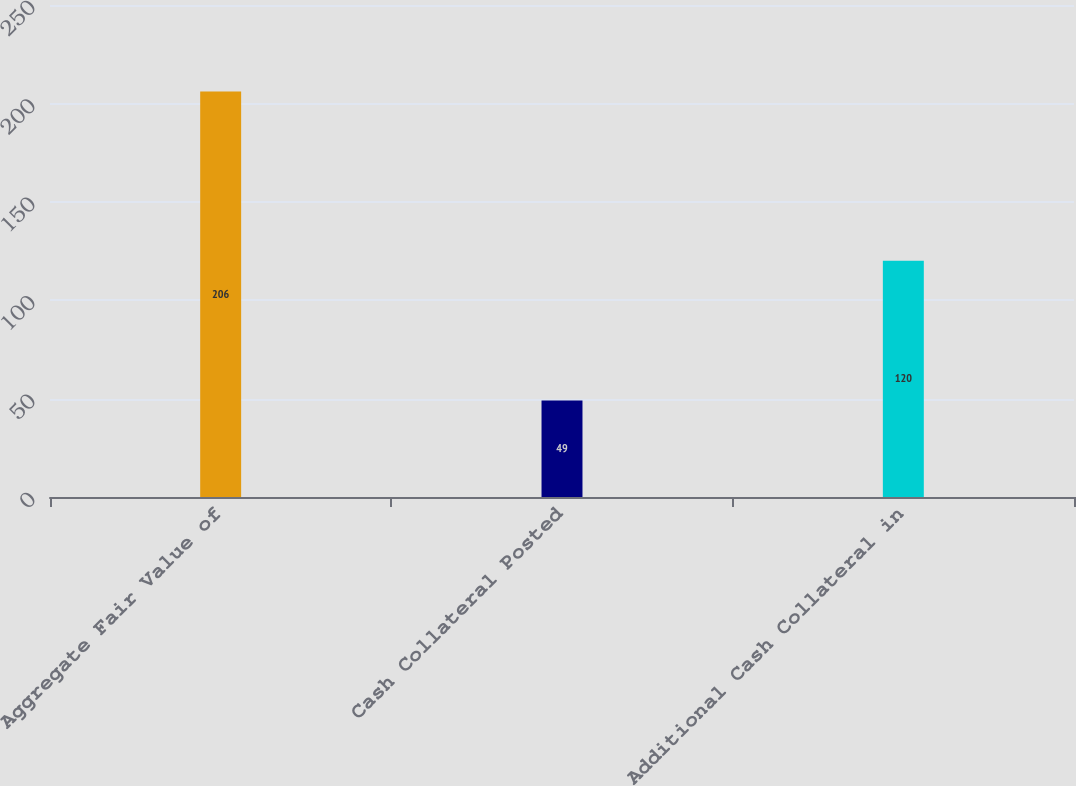Convert chart. <chart><loc_0><loc_0><loc_500><loc_500><bar_chart><fcel>Aggregate Fair Value of<fcel>Cash Collateral Posted<fcel>Additional Cash Collateral in<nl><fcel>206<fcel>49<fcel>120<nl></chart> 